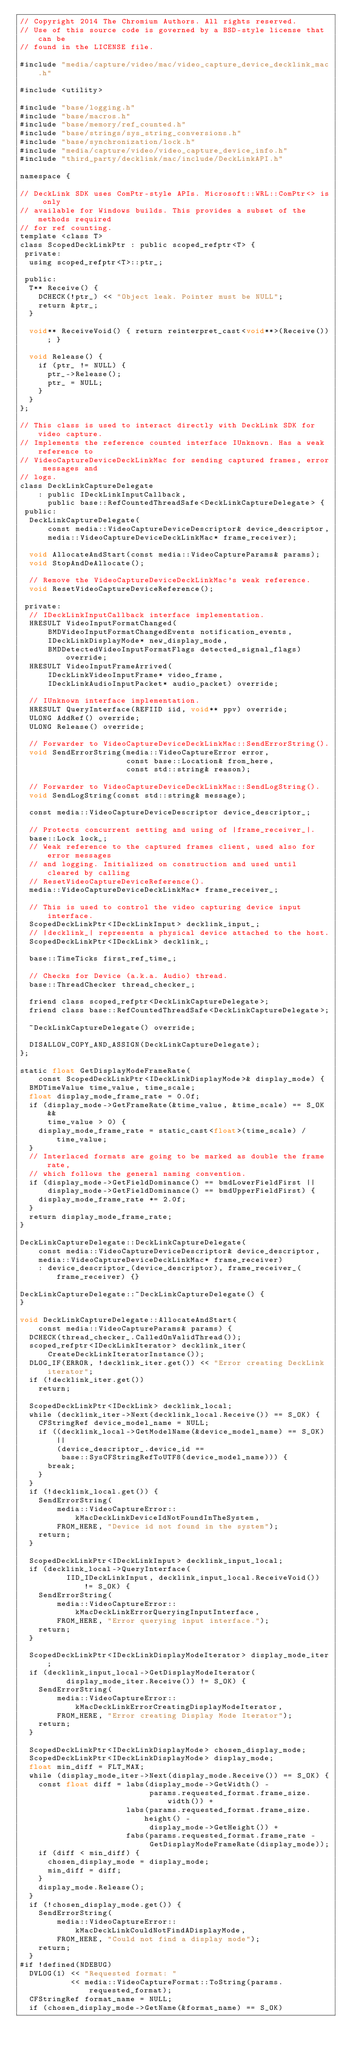Convert code to text. <code><loc_0><loc_0><loc_500><loc_500><_ObjectiveC_>// Copyright 2014 The Chromium Authors. All rights reserved.
// Use of this source code is governed by a BSD-style license that can be
// found in the LICENSE file.

#include "media/capture/video/mac/video_capture_device_decklink_mac.h"

#include <utility>

#include "base/logging.h"
#include "base/macros.h"
#include "base/memory/ref_counted.h"
#include "base/strings/sys_string_conversions.h"
#include "base/synchronization/lock.h"
#include "media/capture/video/video_capture_device_info.h"
#include "third_party/decklink/mac/include/DeckLinkAPI.h"

namespace {

// DeckLink SDK uses ComPtr-style APIs. Microsoft::WRL::ComPtr<> is only
// available for Windows builds. This provides a subset of the methods required
// for ref counting.
template <class T>
class ScopedDeckLinkPtr : public scoped_refptr<T> {
 private:
  using scoped_refptr<T>::ptr_;

 public:
  T** Receive() {
    DCHECK(!ptr_) << "Object leak. Pointer must be NULL";
    return &ptr_;
  }

  void** ReceiveVoid() { return reinterpret_cast<void**>(Receive()); }

  void Release() {
    if (ptr_ != NULL) {
      ptr_->Release();
      ptr_ = NULL;
    }
  }
};

// This class is used to interact directly with DeckLink SDK for video capture.
// Implements the reference counted interface IUnknown. Has a weak reference to
// VideoCaptureDeviceDeckLinkMac for sending captured frames, error messages and
// logs.
class DeckLinkCaptureDelegate
    : public IDeckLinkInputCallback,
      public base::RefCountedThreadSafe<DeckLinkCaptureDelegate> {
 public:
  DeckLinkCaptureDelegate(
      const media::VideoCaptureDeviceDescriptor& device_descriptor,
      media::VideoCaptureDeviceDeckLinkMac* frame_receiver);

  void AllocateAndStart(const media::VideoCaptureParams& params);
  void StopAndDeAllocate();

  // Remove the VideoCaptureDeviceDeckLinkMac's weak reference.
  void ResetVideoCaptureDeviceReference();

 private:
  // IDeckLinkInputCallback interface implementation.
  HRESULT VideoInputFormatChanged(
      BMDVideoInputFormatChangedEvents notification_events,
      IDeckLinkDisplayMode* new_display_mode,
      BMDDetectedVideoInputFormatFlags detected_signal_flags) override;
  HRESULT VideoInputFrameArrived(
      IDeckLinkVideoInputFrame* video_frame,
      IDeckLinkAudioInputPacket* audio_packet) override;

  // IUnknown interface implementation.
  HRESULT QueryInterface(REFIID iid, void** ppv) override;
  ULONG AddRef() override;
  ULONG Release() override;

  // Forwarder to VideoCaptureDeviceDeckLinkMac::SendErrorString().
  void SendErrorString(media::VideoCaptureError error,
                       const base::Location& from_here,
                       const std::string& reason);

  // Forwarder to VideoCaptureDeviceDeckLinkMac::SendLogString().
  void SendLogString(const std::string& message);

  const media::VideoCaptureDeviceDescriptor device_descriptor_;

  // Protects concurrent setting and using of |frame_receiver_|.
  base::Lock lock_;
  // Weak reference to the captured frames client, used also for error messages
  // and logging. Initialized on construction and used until cleared by calling
  // ResetVideoCaptureDeviceReference().
  media::VideoCaptureDeviceDeckLinkMac* frame_receiver_;

  // This is used to control the video capturing device input interface.
  ScopedDeckLinkPtr<IDeckLinkInput> decklink_input_;
  // |decklink_| represents a physical device attached to the host.
  ScopedDeckLinkPtr<IDeckLink> decklink_;

  base::TimeTicks first_ref_time_;

  // Checks for Device (a.k.a. Audio) thread.
  base::ThreadChecker thread_checker_;

  friend class scoped_refptr<DeckLinkCaptureDelegate>;
  friend class base::RefCountedThreadSafe<DeckLinkCaptureDelegate>;

  ~DeckLinkCaptureDelegate() override;

  DISALLOW_COPY_AND_ASSIGN(DeckLinkCaptureDelegate);
};

static float GetDisplayModeFrameRate(
    const ScopedDeckLinkPtr<IDeckLinkDisplayMode>& display_mode) {
  BMDTimeValue time_value, time_scale;
  float display_mode_frame_rate = 0.0f;
  if (display_mode->GetFrameRate(&time_value, &time_scale) == S_OK &&
      time_value > 0) {
    display_mode_frame_rate = static_cast<float>(time_scale) / time_value;
  }
  // Interlaced formats are going to be marked as double the frame rate,
  // which follows the general naming convention.
  if (display_mode->GetFieldDominance() == bmdLowerFieldFirst ||
      display_mode->GetFieldDominance() == bmdUpperFieldFirst) {
    display_mode_frame_rate *= 2.0f;
  }
  return display_mode_frame_rate;
}

DeckLinkCaptureDelegate::DeckLinkCaptureDelegate(
    const media::VideoCaptureDeviceDescriptor& device_descriptor,
    media::VideoCaptureDeviceDeckLinkMac* frame_receiver)
    : device_descriptor_(device_descriptor), frame_receiver_(frame_receiver) {}

DeckLinkCaptureDelegate::~DeckLinkCaptureDelegate() {
}

void DeckLinkCaptureDelegate::AllocateAndStart(
    const media::VideoCaptureParams& params) {
  DCHECK(thread_checker_.CalledOnValidThread());
  scoped_refptr<IDeckLinkIterator> decklink_iter(
      CreateDeckLinkIteratorInstance());
  DLOG_IF(ERROR, !decklink_iter.get()) << "Error creating DeckLink iterator";
  if (!decklink_iter.get())
    return;

  ScopedDeckLinkPtr<IDeckLink> decklink_local;
  while (decklink_iter->Next(decklink_local.Receive()) == S_OK) {
    CFStringRef device_model_name = NULL;
    if ((decklink_local->GetModelName(&device_model_name) == S_OK) ||
        (device_descriptor_.device_id ==
         base::SysCFStringRefToUTF8(device_model_name))) {
      break;
    }
  }
  if (!decklink_local.get()) {
    SendErrorString(
        media::VideoCaptureError::kMacDeckLinkDeviceIdNotFoundInTheSystem,
        FROM_HERE, "Device id not found in the system");
    return;
  }

  ScopedDeckLinkPtr<IDeckLinkInput> decklink_input_local;
  if (decklink_local->QueryInterface(
          IID_IDeckLinkInput, decklink_input_local.ReceiveVoid()) != S_OK) {
    SendErrorString(
        media::VideoCaptureError::kMacDeckLinkErrorQueryingInputInterface,
        FROM_HERE, "Error querying input interface.");
    return;
  }

  ScopedDeckLinkPtr<IDeckLinkDisplayModeIterator> display_mode_iter;
  if (decklink_input_local->GetDisplayModeIterator(
          display_mode_iter.Receive()) != S_OK) {
    SendErrorString(
        media::VideoCaptureError::kMacDeckLinkErrorCreatingDisplayModeIterator,
        FROM_HERE, "Error creating Display Mode Iterator");
    return;
  }

  ScopedDeckLinkPtr<IDeckLinkDisplayMode> chosen_display_mode;
  ScopedDeckLinkPtr<IDeckLinkDisplayMode> display_mode;
  float min_diff = FLT_MAX;
  while (display_mode_iter->Next(display_mode.Receive()) == S_OK) {
    const float diff = labs(display_mode->GetWidth() -
                            params.requested_format.frame_size.width()) +
                       labs(params.requested_format.frame_size.height() -
                            display_mode->GetHeight()) +
                       fabs(params.requested_format.frame_rate -
                            GetDisplayModeFrameRate(display_mode));
    if (diff < min_diff) {
      chosen_display_mode = display_mode;
      min_diff = diff;
    }
    display_mode.Release();
  }
  if (!chosen_display_mode.get()) {
    SendErrorString(
        media::VideoCaptureError::kMacDeckLinkCouldNotFindADisplayMode,
        FROM_HERE, "Could not find a display mode");
    return;
  }
#if !defined(NDEBUG)
  DVLOG(1) << "Requested format: "
           << media::VideoCaptureFormat::ToString(params.requested_format);
  CFStringRef format_name = NULL;
  if (chosen_display_mode->GetName(&format_name) == S_OK)</code> 